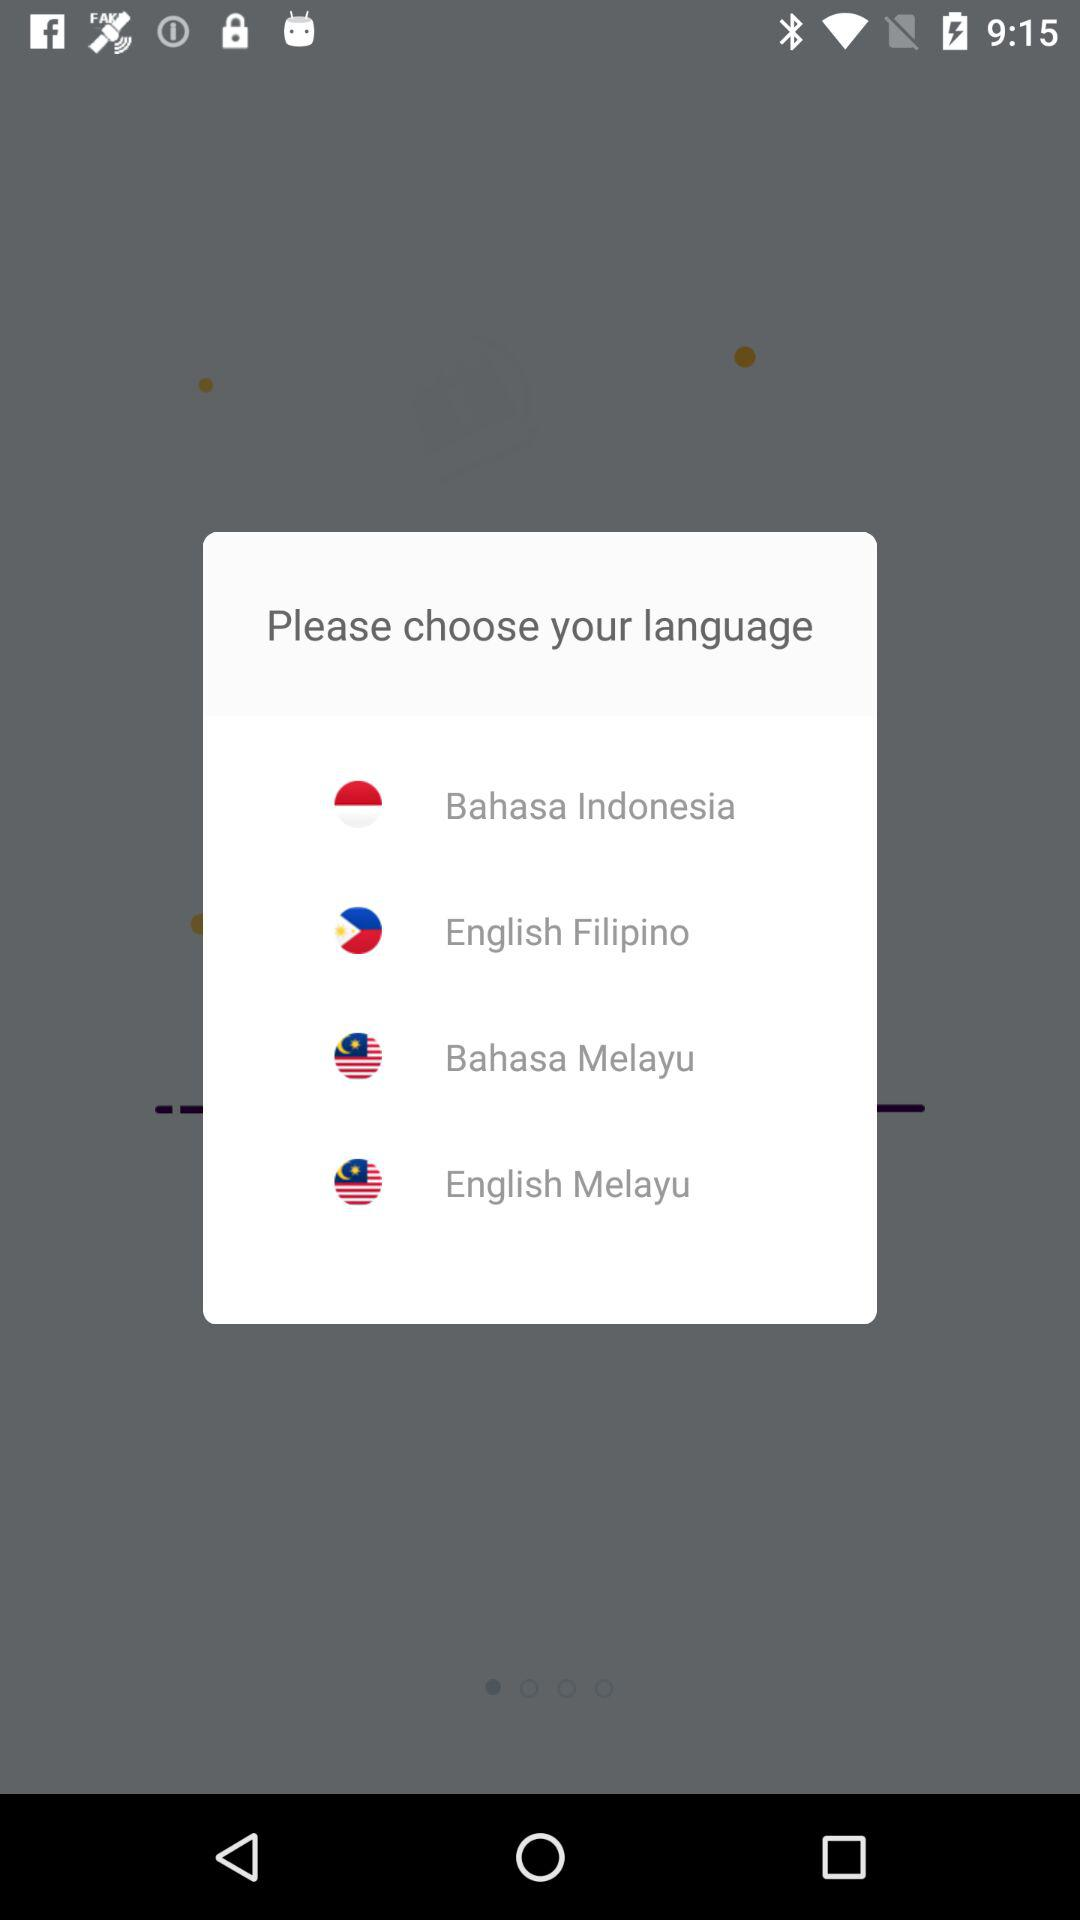How many languages are available to choose from?
Answer the question using a single word or phrase. 4 